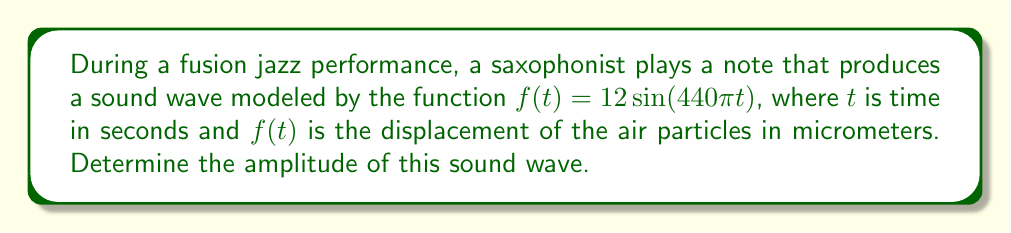Give your solution to this math problem. To solve this problem, we need to understand the components of a sine wave function and how they relate to sound waves in music:

1. The general form of a sine wave function is:

   $$f(t) = A\sin(Bt + C) + D$$

   Where:
   - $A$ is the amplitude
   - $B$ is related to the frequency
   - $C$ is the phase shift
   - $D$ is the vertical shift

2. In our case, we have:

   $$f(t) = 12\sin(440\pi t)$$

3. Comparing this to the general form, we can see that:
   - $A = 12$
   - $B = 440\pi$
   - $C = 0$ (no phase shift)
   - $D = 0$ (no vertical shift)

4. The amplitude of a sine wave is the maximum displacement from the equilibrium position. In a sine function, this is represented by the coefficient $A$.

5. Therefore, the amplitude of the sound wave is 12 micrometers.

Note: In the context of jazz music, this amplitude would contribute to the volume and intensity of the saxophone note. A larger amplitude would result in a louder sound, which could be used for emphasis in a fusion jazz piece or to stand out during a solo performance.
Answer: The amplitude of the sound wave is 12 micrometers. 